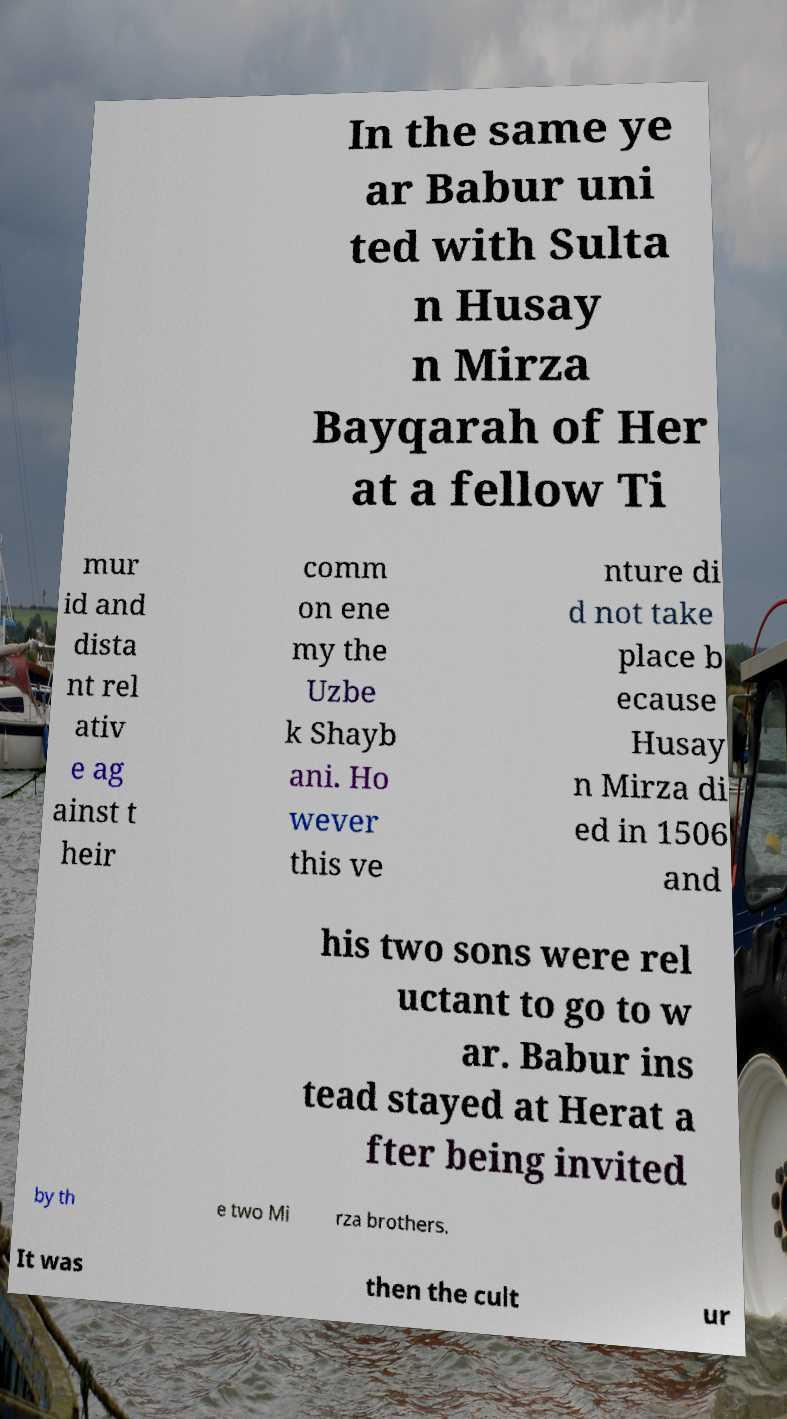I need the written content from this picture converted into text. Can you do that? In the same ye ar Babur uni ted with Sulta n Husay n Mirza Bayqarah of Her at a fellow Ti mur id and dista nt rel ativ e ag ainst t heir comm on ene my the Uzbe k Shayb ani. Ho wever this ve nture di d not take place b ecause Husay n Mirza di ed in 1506 and his two sons were rel uctant to go to w ar. Babur ins tead stayed at Herat a fter being invited by th e two Mi rza brothers. It was then the cult ur 